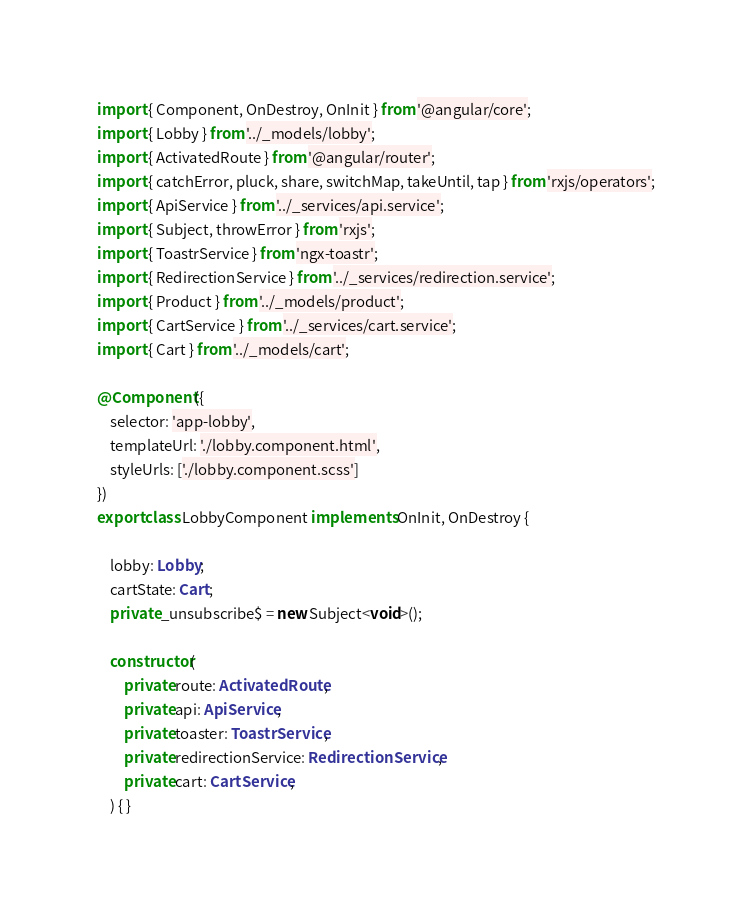<code> <loc_0><loc_0><loc_500><loc_500><_TypeScript_>import { Component, OnDestroy, OnInit } from '@angular/core';
import { Lobby } from '../_models/lobby';
import { ActivatedRoute } from '@angular/router';
import { catchError, pluck, share, switchMap, takeUntil, tap } from 'rxjs/operators';
import { ApiService } from '../_services/api.service';
import { Subject, throwError } from 'rxjs';
import { ToastrService } from 'ngx-toastr';
import { RedirectionService } from '../_services/redirection.service';
import { Product } from '../_models/product';
import { CartService } from '../_services/cart.service';
import { Cart } from '../_models/cart';

@Component({
    selector: 'app-lobby',
    templateUrl: './lobby.component.html',
    styleUrls: ['./lobby.component.scss']
})
export class LobbyComponent implements OnInit, OnDestroy {

    lobby: Lobby;
    cartState: Cart;
    private _unsubscribe$ = new Subject<void>();

    constructor(
        private route: ActivatedRoute,
        private api: ApiService,
        private toaster: ToastrService,
        private redirectionService: RedirectionService,
        private cart: CartService,
    ) { }
</code> 